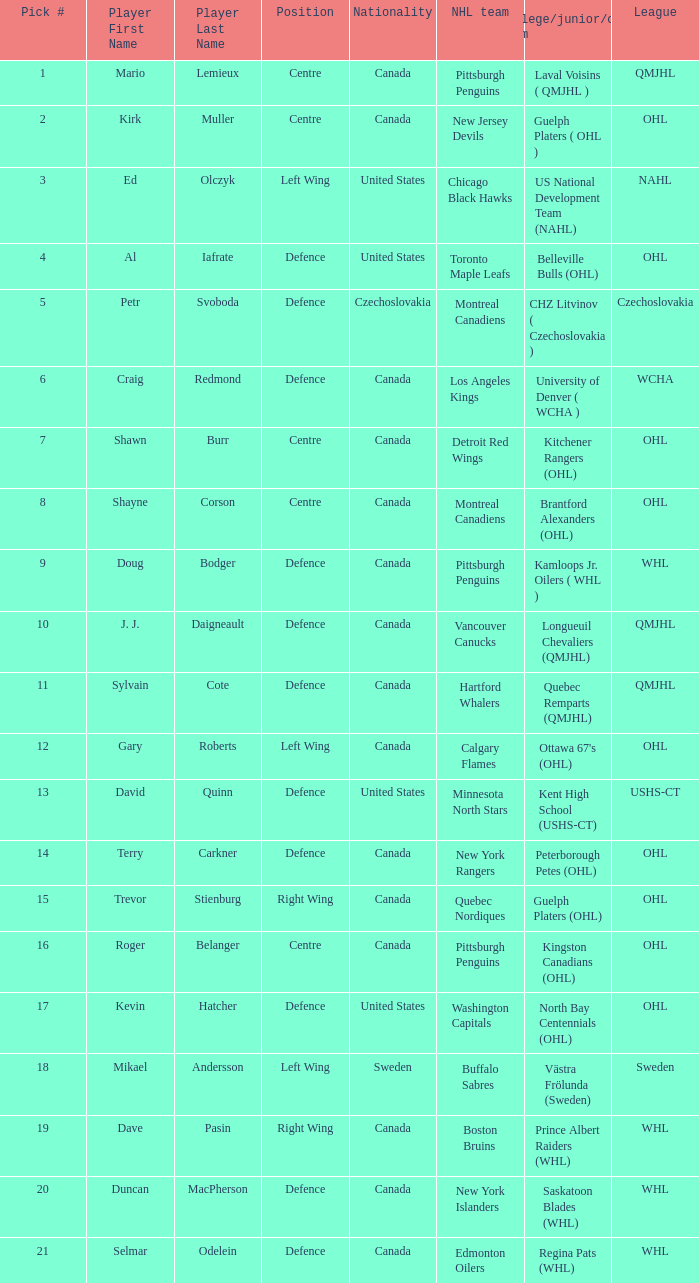What nationality is the draft pick player going to Minnesota North Stars? United States. 